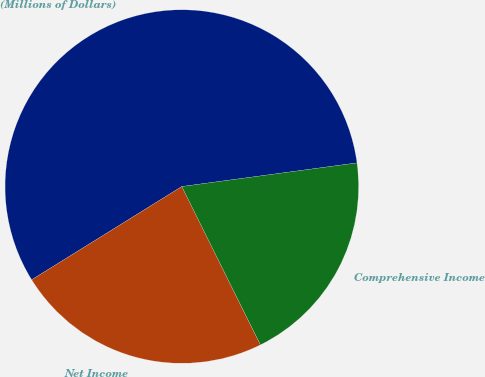Convert chart to OTSL. <chart><loc_0><loc_0><loc_500><loc_500><pie_chart><fcel>(Millions of Dollars)<fcel>Net Income<fcel>Comprehensive Income<nl><fcel>56.71%<fcel>23.49%<fcel>19.8%<nl></chart> 